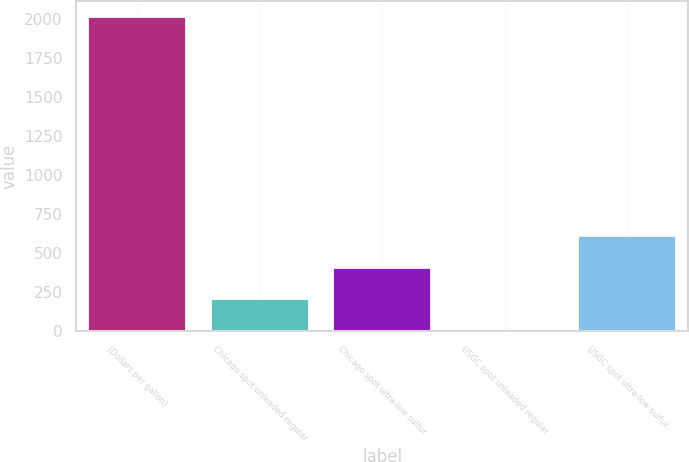<chart> <loc_0><loc_0><loc_500><loc_500><bar_chart><fcel>(Dollars per gallon)<fcel>Chicago spot unleaded regular<fcel>Chicago spot ultra-low sulfur<fcel>USGC spot unleaded regular<fcel>USGC spot ultra-low sulfur<nl><fcel>2012<fcel>203.73<fcel>404.65<fcel>2.81<fcel>605.57<nl></chart> 